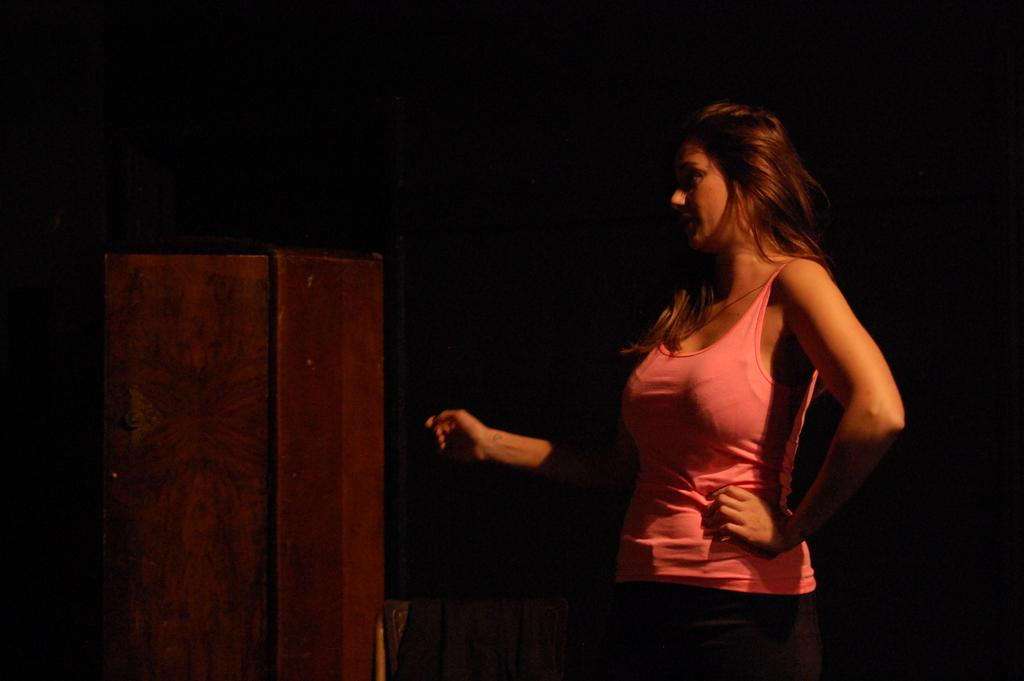Who is present in the image? There is a woman in the image. What is the woman wearing? The woman is wearing a pink top. What can be seen on the left side of the image? There is a wooden cabinet on the left side of the image. How would you describe the overall lighting in the image? The background of the image is dark. What type of list can be seen on the tray in the image? There is no tray or list present in the image. How many houses are visible in the image? There are no houses visible in the image. 